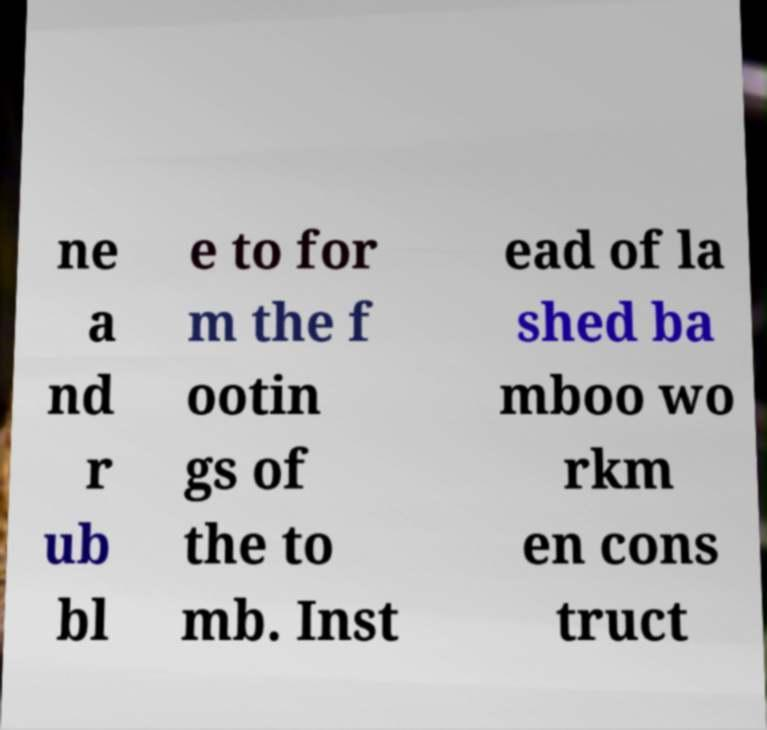What messages or text are displayed in this image? I need them in a readable, typed format. ne a nd r ub bl e to for m the f ootin gs of the to mb. Inst ead of la shed ba mboo wo rkm en cons truct 